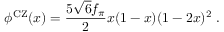<formula> <loc_0><loc_0><loc_500><loc_500>\phi ^ { C Z } ( x ) = \frac { 5 \sqrt { 6 } f _ { \pi } } { 2 } x ( 1 - x ) ( 1 - 2 x ) ^ { 2 } \, .</formula> 